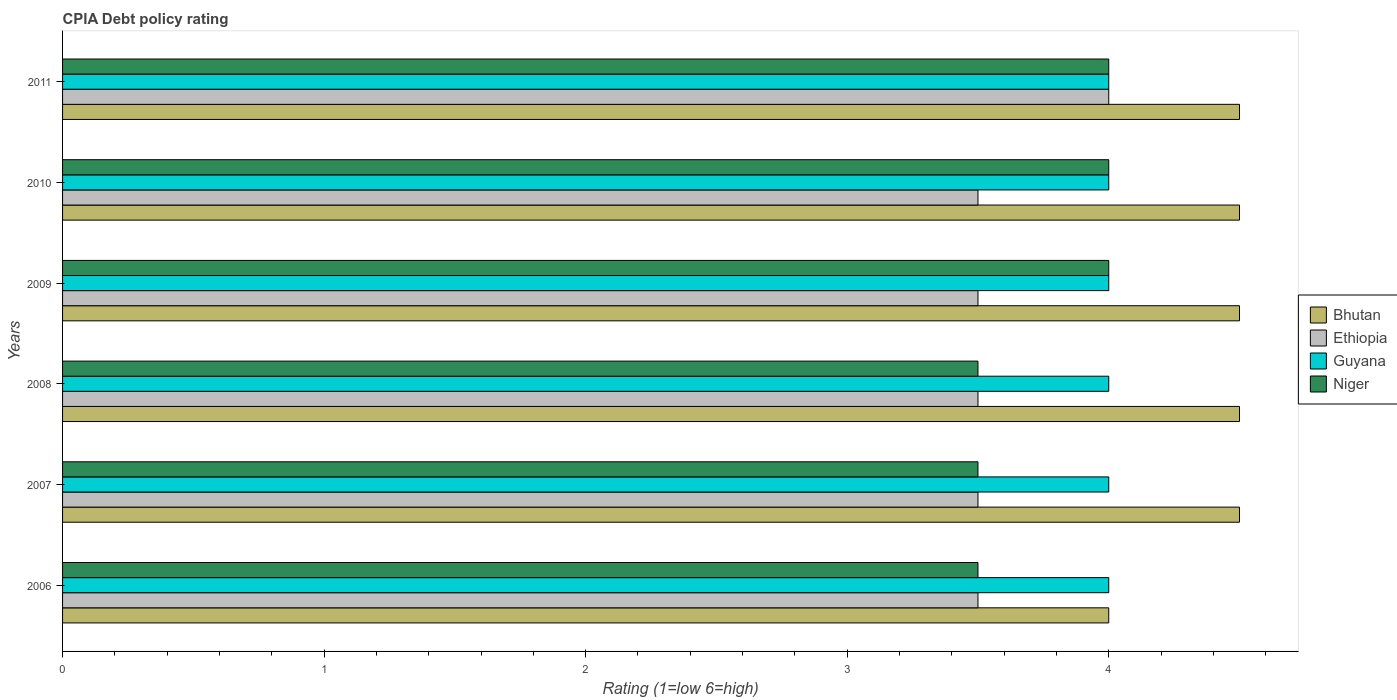How many groups of bars are there?
Your response must be concise. 6. Are the number of bars on each tick of the Y-axis equal?
Provide a short and direct response. Yes. How many bars are there on the 5th tick from the bottom?
Your answer should be compact. 4. What is the label of the 4th group of bars from the top?
Offer a terse response. 2008. In how many cases, is the number of bars for a given year not equal to the number of legend labels?
Make the answer very short. 0. What is the CPIA rating in Ethiopia in 2008?
Your answer should be very brief. 3.5. Across all years, what is the maximum CPIA rating in Niger?
Provide a succinct answer. 4. What is the total CPIA rating in Bhutan in the graph?
Give a very brief answer. 26.5. In the year 2009, what is the difference between the CPIA rating in Guyana and CPIA rating in Ethiopia?
Give a very brief answer. 0.5. In how many years, is the CPIA rating in Guyana greater than 0.2 ?
Make the answer very short. 6. Is the CPIA rating in Guyana in 2009 less than that in 2011?
Provide a short and direct response. No. Is the difference between the CPIA rating in Guyana in 2010 and 2011 greater than the difference between the CPIA rating in Ethiopia in 2010 and 2011?
Offer a very short reply. Yes. In how many years, is the CPIA rating in Guyana greater than the average CPIA rating in Guyana taken over all years?
Provide a succinct answer. 0. Is the sum of the CPIA rating in Ethiopia in 2006 and 2007 greater than the maximum CPIA rating in Niger across all years?
Your response must be concise. Yes. What does the 2nd bar from the top in 2007 represents?
Ensure brevity in your answer.  Guyana. What does the 1st bar from the bottom in 2009 represents?
Offer a terse response. Bhutan. How many bars are there?
Offer a very short reply. 24. Are all the bars in the graph horizontal?
Make the answer very short. Yes. How many years are there in the graph?
Your answer should be compact. 6. Are the values on the major ticks of X-axis written in scientific E-notation?
Your answer should be compact. No. Where does the legend appear in the graph?
Offer a terse response. Center right. How many legend labels are there?
Give a very brief answer. 4. What is the title of the graph?
Ensure brevity in your answer.  CPIA Debt policy rating. What is the label or title of the X-axis?
Your answer should be compact. Rating (1=low 6=high). What is the Rating (1=low 6=high) in Niger in 2006?
Ensure brevity in your answer.  3.5. What is the Rating (1=low 6=high) in Bhutan in 2007?
Offer a terse response. 4.5. What is the Rating (1=low 6=high) of Guyana in 2007?
Keep it short and to the point. 4. What is the Rating (1=low 6=high) in Bhutan in 2008?
Your answer should be very brief. 4.5. What is the Rating (1=low 6=high) in Guyana in 2008?
Offer a very short reply. 4. What is the Rating (1=low 6=high) of Ethiopia in 2009?
Give a very brief answer. 3.5. What is the Rating (1=low 6=high) of Guyana in 2009?
Make the answer very short. 4. What is the Rating (1=low 6=high) in Niger in 2009?
Make the answer very short. 4. What is the Rating (1=low 6=high) in Ethiopia in 2010?
Make the answer very short. 3.5. What is the Rating (1=low 6=high) of Guyana in 2010?
Make the answer very short. 4. What is the Rating (1=low 6=high) of Guyana in 2011?
Offer a very short reply. 4. Across all years, what is the maximum Rating (1=low 6=high) in Ethiopia?
Offer a very short reply. 4. Across all years, what is the maximum Rating (1=low 6=high) of Guyana?
Your answer should be compact. 4. Across all years, what is the maximum Rating (1=low 6=high) in Niger?
Give a very brief answer. 4. Across all years, what is the minimum Rating (1=low 6=high) of Guyana?
Provide a short and direct response. 4. What is the total Rating (1=low 6=high) of Niger in the graph?
Provide a succinct answer. 22.5. What is the difference between the Rating (1=low 6=high) in Bhutan in 2006 and that in 2007?
Keep it short and to the point. -0.5. What is the difference between the Rating (1=low 6=high) in Ethiopia in 2006 and that in 2007?
Ensure brevity in your answer.  0. What is the difference between the Rating (1=low 6=high) in Niger in 2006 and that in 2007?
Your answer should be very brief. 0. What is the difference between the Rating (1=low 6=high) of Bhutan in 2006 and that in 2008?
Keep it short and to the point. -0.5. What is the difference between the Rating (1=low 6=high) in Guyana in 2006 and that in 2008?
Your response must be concise. 0. What is the difference between the Rating (1=low 6=high) in Niger in 2006 and that in 2008?
Offer a very short reply. 0. What is the difference between the Rating (1=low 6=high) of Ethiopia in 2006 and that in 2009?
Keep it short and to the point. 0. What is the difference between the Rating (1=low 6=high) of Bhutan in 2006 and that in 2010?
Give a very brief answer. -0.5. What is the difference between the Rating (1=low 6=high) of Ethiopia in 2006 and that in 2010?
Give a very brief answer. 0. What is the difference between the Rating (1=low 6=high) in Bhutan in 2006 and that in 2011?
Offer a very short reply. -0.5. What is the difference between the Rating (1=low 6=high) of Guyana in 2006 and that in 2011?
Make the answer very short. 0. What is the difference between the Rating (1=low 6=high) in Niger in 2006 and that in 2011?
Keep it short and to the point. -0.5. What is the difference between the Rating (1=low 6=high) of Ethiopia in 2007 and that in 2009?
Keep it short and to the point. 0. What is the difference between the Rating (1=low 6=high) of Guyana in 2007 and that in 2009?
Your response must be concise. 0. What is the difference between the Rating (1=low 6=high) of Niger in 2007 and that in 2010?
Your answer should be compact. -0.5. What is the difference between the Rating (1=low 6=high) of Ethiopia in 2007 and that in 2011?
Give a very brief answer. -0.5. What is the difference between the Rating (1=low 6=high) of Niger in 2007 and that in 2011?
Provide a short and direct response. -0.5. What is the difference between the Rating (1=low 6=high) of Bhutan in 2008 and that in 2009?
Give a very brief answer. 0. What is the difference between the Rating (1=low 6=high) of Ethiopia in 2008 and that in 2009?
Offer a very short reply. 0. What is the difference between the Rating (1=low 6=high) of Guyana in 2008 and that in 2009?
Your answer should be very brief. 0. What is the difference between the Rating (1=low 6=high) in Guyana in 2008 and that in 2010?
Make the answer very short. 0. What is the difference between the Rating (1=low 6=high) in Niger in 2008 and that in 2010?
Offer a terse response. -0.5. What is the difference between the Rating (1=low 6=high) in Bhutan in 2008 and that in 2011?
Ensure brevity in your answer.  0. What is the difference between the Rating (1=low 6=high) of Ethiopia in 2008 and that in 2011?
Your answer should be very brief. -0.5. What is the difference between the Rating (1=low 6=high) of Bhutan in 2009 and that in 2010?
Offer a very short reply. 0. What is the difference between the Rating (1=low 6=high) of Niger in 2009 and that in 2010?
Ensure brevity in your answer.  0. What is the difference between the Rating (1=low 6=high) of Ethiopia in 2009 and that in 2011?
Your answer should be very brief. -0.5. What is the difference between the Rating (1=low 6=high) in Niger in 2009 and that in 2011?
Give a very brief answer. 0. What is the difference between the Rating (1=low 6=high) of Bhutan in 2010 and that in 2011?
Offer a terse response. 0. What is the difference between the Rating (1=low 6=high) in Guyana in 2010 and that in 2011?
Your answer should be very brief. 0. What is the difference between the Rating (1=low 6=high) in Niger in 2010 and that in 2011?
Keep it short and to the point. 0. What is the difference between the Rating (1=low 6=high) of Bhutan in 2006 and the Rating (1=low 6=high) of Guyana in 2007?
Offer a terse response. 0. What is the difference between the Rating (1=low 6=high) of Bhutan in 2006 and the Rating (1=low 6=high) of Niger in 2007?
Offer a terse response. 0.5. What is the difference between the Rating (1=low 6=high) of Ethiopia in 2006 and the Rating (1=low 6=high) of Guyana in 2007?
Make the answer very short. -0.5. What is the difference between the Rating (1=low 6=high) of Ethiopia in 2006 and the Rating (1=low 6=high) of Niger in 2007?
Your answer should be very brief. 0. What is the difference between the Rating (1=low 6=high) of Bhutan in 2006 and the Rating (1=low 6=high) of Ethiopia in 2008?
Make the answer very short. 0.5. What is the difference between the Rating (1=low 6=high) in Bhutan in 2006 and the Rating (1=low 6=high) in Guyana in 2008?
Offer a very short reply. 0. What is the difference between the Rating (1=low 6=high) of Bhutan in 2006 and the Rating (1=low 6=high) of Niger in 2008?
Ensure brevity in your answer.  0.5. What is the difference between the Rating (1=low 6=high) of Ethiopia in 2006 and the Rating (1=low 6=high) of Guyana in 2008?
Make the answer very short. -0.5. What is the difference between the Rating (1=low 6=high) of Ethiopia in 2006 and the Rating (1=low 6=high) of Niger in 2008?
Offer a very short reply. 0. What is the difference between the Rating (1=low 6=high) in Bhutan in 2006 and the Rating (1=low 6=high) in Ethiopia in 2009?
Give a very brief answer. 0.5. What is the difference between the Rating (1=low 6=high) in Bhutan in 2006 and the Rating (1=low 6=high) in Guyana in 2009?
Give a very brief answer. 0. What is the difference between the Rating (1=low 6=high) of Ethiopia in 2006 and the Rating (1=low 6=high) of Niger in 2009?
Your answer should be compact. -0.5. What is the difference between the Rating (1=low 6=high) in Guyana in 2006 and the Rating (1=low 6=high) in Niger in 2009?
Your answer should be very brief. 0. What is the difference between the Rating (1=low 6=high) of Bhutan in 2006 and the Rating (1=low 6=high) of Ethiopia in 2010?
Keep it short and to the point. 0.5. What is the difference between the Rating (1=low 6=high) of Bhutan in 2006 and the Rating (1=low 6=high) of Guyana in 2010?
Provide a short and direct response. 0. What is the difference between the Rating (1=low 6=high) in Ethiopia in 2006 and the Rating (1=low 6=high) in Guyana in 2010?
Offer a terse response. -0.5. What is the difference between the Rating (1=low 6=high) in Bhutan in 2006 and the Rating (1=low 6=high) in Guyana in 2011?
Offer a very short reply. 0. What is the difference between the Rating (1=low 6=high) of Ethiopia in 2006 and the Rating (1=low 6=high) of Guyana in 2011?
Provide a short and direct response. -0.5. What is the difference between the Rating (1=low 6=high) in Ethiopia in 2006 and the Rating (1=low 6=high) in Niger in 2011?
Your answer should be compact. -0.5. What is the difference between the Rating (1=low 6=high) in Guyana in 2006 and the Rating (1=low 6=high) in Niger in 2011?
Offer a very short reply. 0. What is the difference between the Rating (1=low 6=high) of Bhutan in 2007 and the Rating (1=low 6=high) of Ethiopia in 2008?
Ensure brevity in your answer.  1. What is the difference between the Rating (1=low 6=high) of Bhutan in 2007 and the Rating (1=low 6=high) of Guyana in 2008?
Give a very brief answer. 0.5. What is the difference between the Rating (1=low 6=high) of Bhutan in 2007 and the Rating (1=low 6=high) of Niger in 2008?
Give a very brief answer. 1. What is the difference between the Rating (1=low 6=high) in Ethiopia in 2007 and the Rating (1=low 6=high) in Guyana in 2008?
Provide a short and direct response. -0.5. What is the difference between the Rating (1=low 6=high) in Bhutan in 2007 and the Rating (1=low 6=high) in Ethiopia in 2009?
Give a very brief answer. 1. What is the difference between the Rating (1=low 6=high) in Bhutan in 2007 and the Rating (1=low 6=high) in Guyana in 2009?
Give a very brief answer. 0.5. What is the difference between the Rating (1=low 6=high) of Ethiopia in 2007 and the Rating (1=low 6=high) of Guyana in 2009?
Offer a terse response. -0.5. What is the difference between the Rating (1=low 6=high) of Ethiopia in 2007 and the Rating (1=low 6=high) of Niger in 2009?
Provide a short and direct response. -0.5. What is the difference between the Rating (1=low 6=high) in Guyana in 2007 and the Rating (1=low 6=high) in Niger in 2009?
Give a very brief answer. 0. What is the difference between the Rating (1=low 6=high) in Bhutan in 2007 and the Rating (1=low 6=high) in Ethiopia in 2010?
Provide a short and direct response. 1. What is the difference between the Rating (1=low 6=high) of Ethiopia in 2007 and the Rating (1=low 6=high) of Guyana in 2010?
Your response must be concise. -0.5. What is the difference between the Rating (1=low 6=high) of Ethiopia in 2007 and the Rating (1=low 6=high) of Guyana in 2011?
Your response must be concise. -0.5. What is the difference between the Rating (1=low 6=high) of Guyana in 2007 and the Rating (1=low 6=high) of Niger in 2011?
Your response must be concise. 0. What is the difference between the Rating (1=low 6=high) in Bhutan in 2008 and the Rating (1=low 6=high) in Ethiopia in 2009?
Your answer should be compact. 1. What is the difference between the Rating (1=low 6=high) of Ethiopia in 2008 and the Rating (1=low 6=high) of Guyana in 2009?
Offer a very short reply. -0.5. What is the difference between the Rating (1=low 6=high) of Ethiopia in 2008 and the Rating (1=low 6=high) of Niger in 2009?
Ensure brevity in your answer.  -0.5. What is the difference between the Rating (1=low 6=high) in Bhutan in 2008 and the Rating (1=low 6=high) in Ethiopia in 2010?
Keep it short and to the point. 1. What is the difference between the Rating (1=low 6=high) in Ethiopia in 2008 and the Rating (1=low 6=high) in Guyana in 2010?
Give a very brief answer. -0.5. What is the difference between the Rating (1=low 6=high) in Ethiopia in 2008 and the Rating (1=low 6=high) in Niger in 2010?
Give a very brief answer. -0.5. What is the difference between the Rating (1=low 6=high) in Bhutan in 2008 and the Rating (1=low 6=high) in Ethiopia in 2011?
Give a very brief answer. 0.5. What is the difference between the Rating (1=low 6=high) in Bhutan in 2008 and the Rating (1=low 6=high) in Guyana in 2011?
Ensure brevity in your answer.  0.5. What is the difference between the Rating (1=low 6=high) of Ethiopia in 2008 and the Rating (1=low 6=high) of Guyana in 2011?
Give a very brief answer. -0.5. What is the difference between the Rating (1=low 6=high) of Ethiopia in 2009 and the Rating (1=low 6=high) of Guyana in 2010?
Offer a terse response. -0.5. What is the difference between the Rating (1=low 6=high) in Guyana in 2009 and the Rating (1=low 6=high) in Niger in 2010?
Make the answer very short. 0. What is the difference between the Rating (1=low 6=high) of Bhutan in 2009 and the Rating (1=low 6=high) of Ethiopia in 2011?
Give a very brief answer. 0.5. What is the difference between the Rating (1=low 6=high) in Bhutan in 2009 and the Rating (1=low 6=high) in Guyana in 2011?
Make the answer very short. 0.5. What is the difference between the Rating (1=low 6=high) in Bhutan in 2009 and the Rating (1=low 6=high) in Niger in 2011?
Your answer should be compact. 0.5. What is the difference between the Rating (1=low 6=high) in Guyana in 2009 and the Rating (1=low 6=high) in Niger in 2011?
Offer a very short reply. 0. What is the difference between the Rating (1=low 6=high) in Bhutan in 2010 and the Rating (1=low 6=high) in Niger in 2011?
Provide a succinct answer. 0.5. What is the difference between the Rating (1=low 6=high) of Guyana in 2010 and the Rating (1=low 6=high) of Niger in 2011?
Your response must be concise. 0. What is the average Rating (1=low 6=high) in Bhutan per year?
Keep it short and to the point. 4.42. What is the average Rating (1=low 6=high) of Ethiopia per year?
Provide a short and direct response. 3.58. What is the average Rating (1=low 6=high) in Niger per year?
Offer a terse response. 3.75. In the year 2006, what is the difference between the Rating (1=low 6=high) in Bhutan and Rating (1=low 6=high) in Guyana?
Ensure brevity in your answer.  0. In the year 2006, what is the difference between the Rating (1=low 6=high) in Bhutan and Rating (1=low 6=high) in Niger?
Provide a succinct answer. 0.5. In the year 2006, what is the difference between the Rating (1=low 6=high) of Ethiopia and Rating (1=low 6=high) of Niger?
Offer a terse response. 0. In the year 2007, what is the difference between the Rating (1=low 6=high) of Bhutan and Rating (1=low 6=high) of Ethiopia?
Offer a terse response. 1. In the year 2007, what is the difference between the Rating (1=low 6=high) in Bhutan and Rating (1=low 6=high) in Guyana?
Offer a very short reply. 0.5. In the year 2007, what is the difference between the Rating (1=low 6=high) of Bhutan and Rating (1=low 6=high) of Niger?
Provide a succinct answer. 1. In the year 2007, what is the difference between the Rating (1=low 6=high) of Ethiopia and Rating (1=low 6=high) of Niger?
Offer a very short reply. 0. In the year 2007, what is the difference between the Rating (1=low 6=high) in Guyana and Rating (1=low 6=high) in Niger?
Keep it short and to the point. 0.5. In the year 2008, what is the difference between the Rating (1=low 6=high) of Bhutan and Rating (1=low 6=high) of Guyana?
Provide a succinct answer. 0.5. In the year 2008, what is the difference between the Rating (1=low 6=high) of Ethiopia and Rating (1=low 6=high) of Guyana?
Provide a short and direct response. -0.5. In the year 2008, what is the difference between the Rating (1=low 6=high) in Ethiopia and Rating (1=low 6=high) in Niger?
Your answer should be very brief. 0. In the year 2009, what is the difference between the Rating (1=low 6=high) in Bhutan and Rating (1=low 6=high) in Ethiopia?
Provide a succinct answer. 1. In the year 2009, what is the difference between the Rating (1=low 6=high) of Ethiopia and Rating (1=low 6=high) of Niger?
Your answer should be very brief. -0.5. In the year 2010, what is the difference between the Rating (1=low 6=high) of Bhutan and Rating (1=low 6=high) of Ethiopia?
Provide a succinct answer. 1. In the year 2010, what is the difference between the Rating (1=low 6=high) in Bhutan and Rating (1=low 6=high) in Guyana?
Make the answer very short. 0.5. In the year 2011, what is the difference between the Rating (1=low 6=high) of Bhutan and Rating (1=low 6=high) of Ethiopia?
Keep it short and to the point. 0.5. In the year 2011, what is the difference between the Rating (1=low 6=high) of Bhutan and Rating (1=low 6=high) of Guyana?
Provide a succinct answer. 0.5. In the year 2011, what is the difference between the Rating (1=low 6=high) in Ethiopia and Rating (1=low 6=high) in Guyana?
Your answer should be compact. 0. What is the ratio of the Rating (1=low 6=high) of Ethiopia in 2006 to that in 2007?
Your answer should be very brief. 1. What is the ratio of the Rating (1=low 6=high) of Ethiopia in 2006 to that in 2008?
Provide a short and direct response. 1. What is the ratio of the Rating (1=low 6=high) in Niger in 2006 to that in 2008?
Keep it short and to the point. 1. What is the ratio of the Rating (1=low 6=high) of Ethiopia in 2006 to that in 2009?
Offer a terse response. 1. What is the ratio of the Rating (1=low 6=high) in Niger in 2006 to that in 2009?
Offer a terse response. 0.88. What is the ratio of the Rating (1=low 6=high) in Guyana in 2006 to that in 2010?
Offer a very short reply. 1. What is the ratio of the Rating (1=low 6=high) of Guyana in 2006 to that in 2011?
Provide a succinct answer. 1. What is the ratio of the Rating (1=low 6=high) in Ethiopia in 2007 to that in 2008?
Make the answer very short. 1. What is the ratio of the Rating (1=low 6=high) of Bhutan in 2007 to that in 2009?
Your answer should be compact. 1. What is the ratio of the Rating (1=low 6=high) of Ethiopia in 2007 to that in 2009?
Offer a very short reply. 1. What is the ratio of the Rating (1=low 6=high) in Guyana in 2007 to that in 2009?
Your response must be concise. 1. What is the ratio of the Rating (1=low 6=high) of Niger in 2007 to that in 2009?
Your response must be concise. 0.88. What is the ratio of the Rating (1=low 6=high) in Guyana in 2007 to that in 2010?
Make the answer very short. 1. What is the ratio of the Rating (1=low 6=high) in Niger in 2007 to that in 2010?
Provide a succinct answer. 0.88. What is the ratio of the Rating (1=low 6=high) in Guyana in 2007 to that in 2011?
Offer a very short reply. 1. What is the ratio of the Rating (1=low 6=high) in Bhutan in 2008 to that in 2009?
Offer a terse response. 1. What is the ratio of the Rating (1=low 6=high) of Niger in 2008 to that in 2009?
Provide a succinct answer. 0.88. What is the ratio of the Rating (1=low 6=high) in Bhutan in 2008 to that in 2010?
Provide a succinct answer. 1. What is the ratio of the Rating (1=low 6=high) of Ethiopia in 2008 to that in 2010?
Your answer should be compact. 1. What is the ratio of the Rating (1=low 6=high) of Bhutan in 2008 to that in 2011?
Provide a succinct answer. 1. What is the ratio of the Rating (1=low 6=high) of Ethiopia in 2008 to that in 2011?
Give a very brief answer. 0.88. What is the ratio of the Rating (1=low 6=high) of Bhutan in 2009 to that in 2010?
Your answer should be compact. 1. What is the ratio of the Rating (1=low 6=high) in Guyana in 2009 to that in 2010?
Make the answer very short. 1. What is the ratio of the Rating (1=low 6=high) in Bhutan in 2009 to that in 2011?
Keep it short and to the point. 1. What is the ratio of the Rating (1=low 6=high) in Guyana in 2009 to that in 2011?
Provide a succinct answer. 1. What is the ratio of the Rating (1=low 6=high) of Niger in 2010 to that in 2011?
Make the answer very short. 1. What is the difference between the highest and the second highest Rating (1=low 6=high) of Bhutan?
Offer a very short reply. 0. What is the difference between the highest and the second highest Rating (1=low 6=high) of Ethiopia?
Give a very brief answer. 0.5. What is the difference between the highest and the second highest Rating (1=low 6=high) of Guyana?
Give a very brief answer. 0. What is the difference between the highest and the second highest Rating (1=low 6=high) in Niger?
Provide a short and direct response. 0. What is the difference between the highest and the lowest Rating (1=low 6=high) of Bhutan?
Give a very brief answer. 0.5. What is the difference between the highest and the lowest Rating (1=low 6=high) in Niger?
Your answer should be very brief. 0.5. 